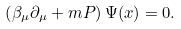<formula> <loc_0><loc_0><loc_500><loc_500>\left ( \beta _ { \mu } \partial _ { \mu } + m P \right ) \Psi ( x ) = 0 .</formula> 